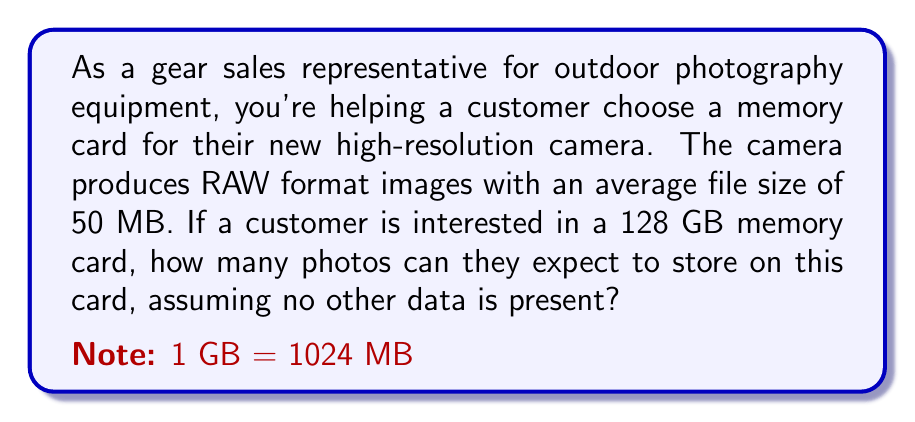Can you solve this math problem? To solve this problem, we need to follow these steps:

1. Convert the memory card capacity from GB to MB:
   $$ 128 \text{ GB} \times 1024 \text{ MB/GB} = 131072 \text{ MB} $$

2. Set up an equation to represent the number of photos:
   Let $x$ be the number of photos.
   $$ 50x = 131072 $$

   This equation represents that the total space used by the photos (50 MB each) should equal the available space on the card (131072 MB).

3. Solve for $x$:
   $$ x = \frac{131072}{50} = 2621.44 $$

4. Since we can't store a fraction of a photo, we need to round down to the nearest whole number:
   $$ \lfloor 2621.44 \rfloor = 2621 $$

Therefore, the maximum number of 50 MB photos that can be stored on a 128 GB memory card is 2621.
Answer: 2621 photos 